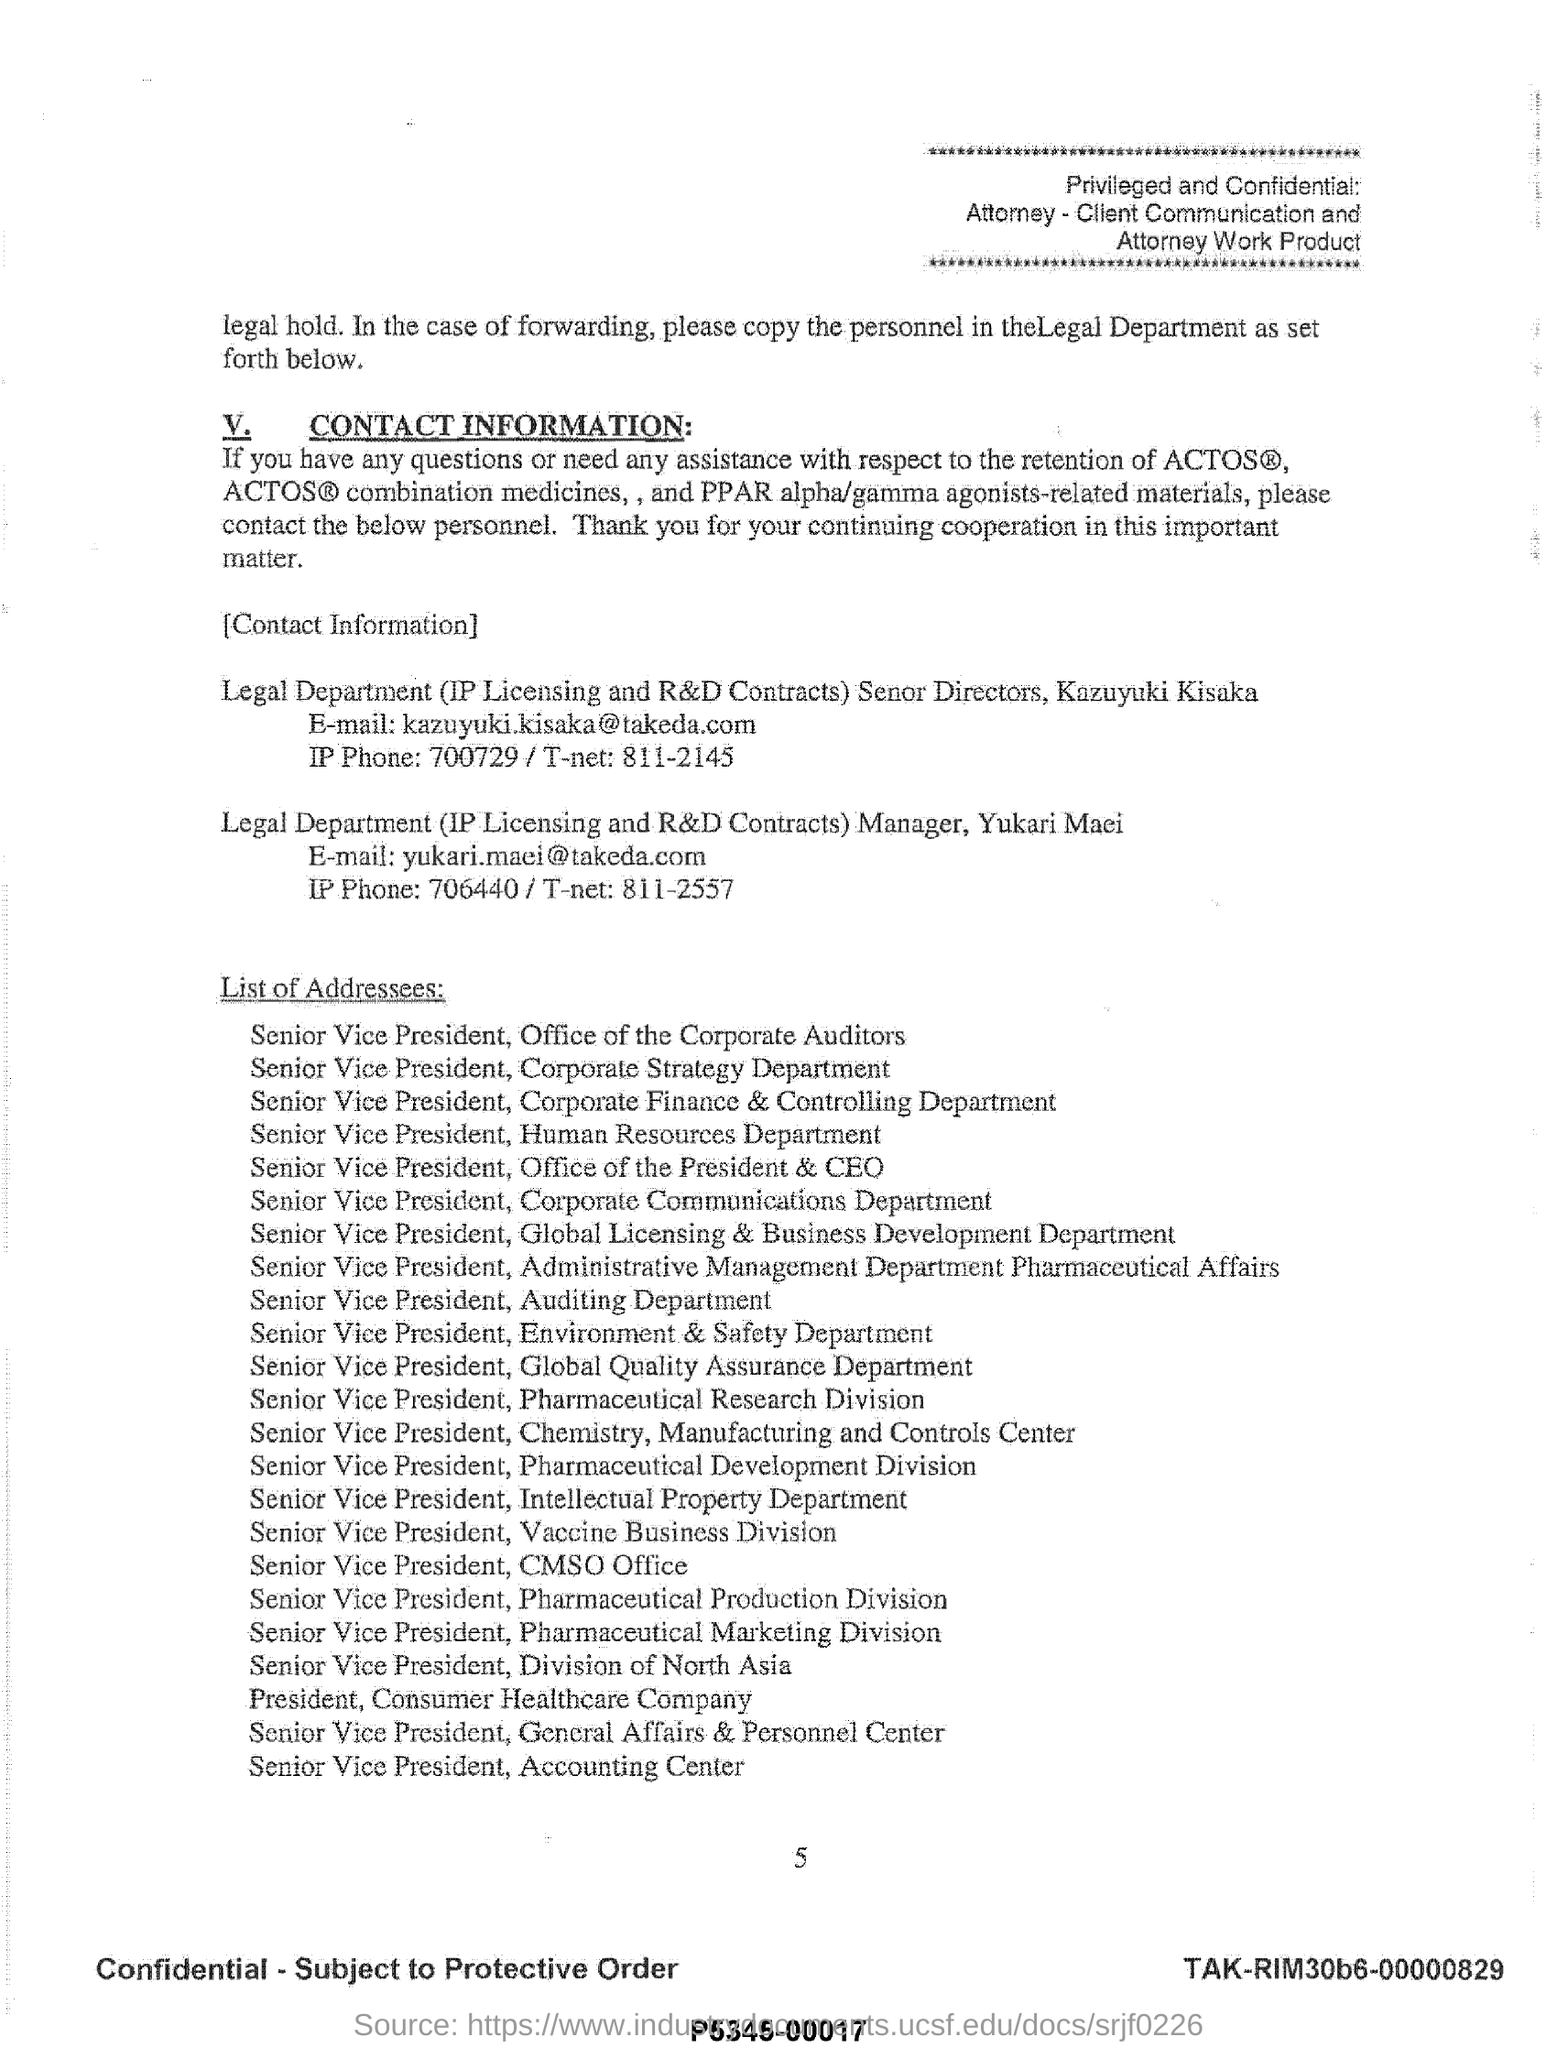Who is the 23rd Addressee mentioned in the list?
Keep it short and to the point. Senior Vice President, Accounting Center. 